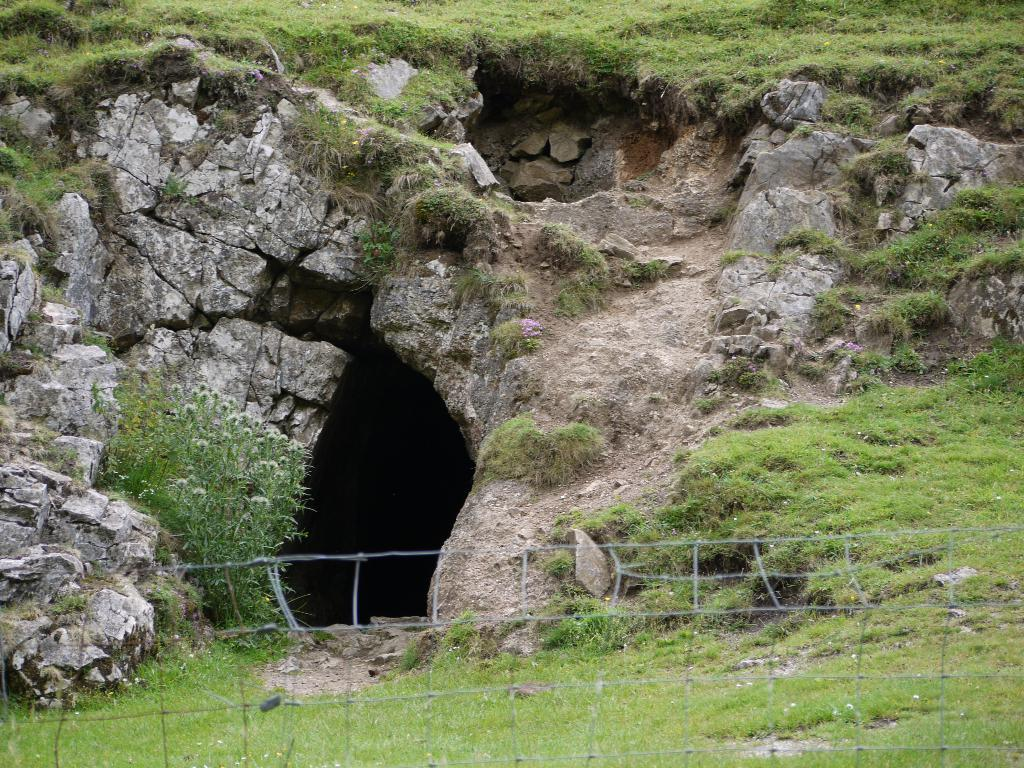What type of natural environment is depicted in the image? The image contains grass and rocks, which suggests a natural environment. What type of structure can be seen in the image? There is a cave in the image. What object is used for catching or holding items in the image? There is a net in the image. Can you see a squirrel sitting on the table in the image? There is no table or squirrel present in the image. What is the temperature like in the image? The provided facts do not give any information about the temperature or heat in the image. 